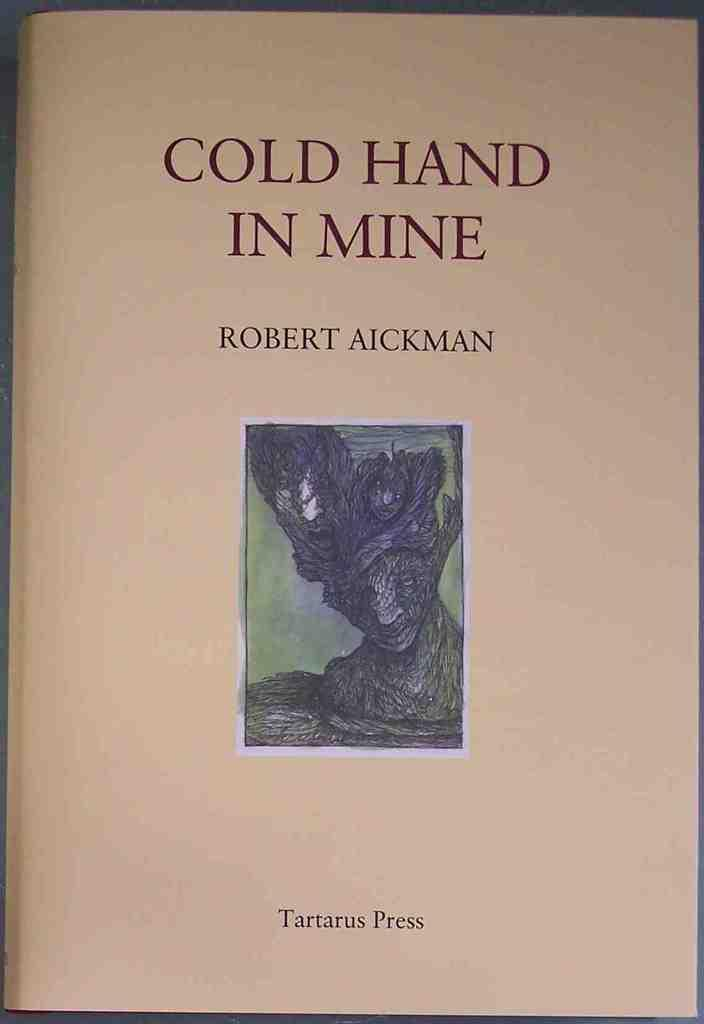<image>
Relay a brief, clear account of the picture shown. A book with a dark illustration written by Robert Aickman. 